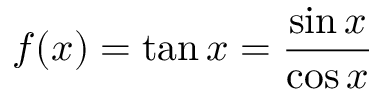<formula> <loc_0><loc_0><loc_500><loc_500>f ( x ) = \tan x = { \frac { \sin x } { \cos x } }</formula> 